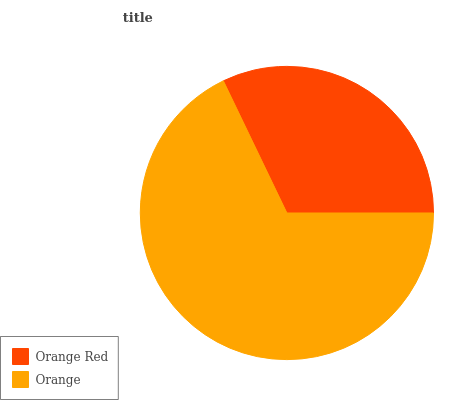Is Orange Red the minimum?
Answer yes or no. Yes. Is Orange the maximum?
Answer yes or no. Yes. Is Orange the minimum?
Answer yes or no. No. Is Orange greater than Orange Red?
Answer yes or no. Yes. Is Orange Red less than Orange?
Answer yes or no. Yes. Is Orange Red greater than Orange?
Answer yes or no. No. Is Orange less than Orange Red?
Answer yes or no. No. Is Orange the high median?
Answer yes or no. Yes. Is Orange Red the low median?
Answer yes or no. Yes. Is Orange Red the high median?
Answer yes or no. No. Is Orange the low median?
Answer yes or no. No. 